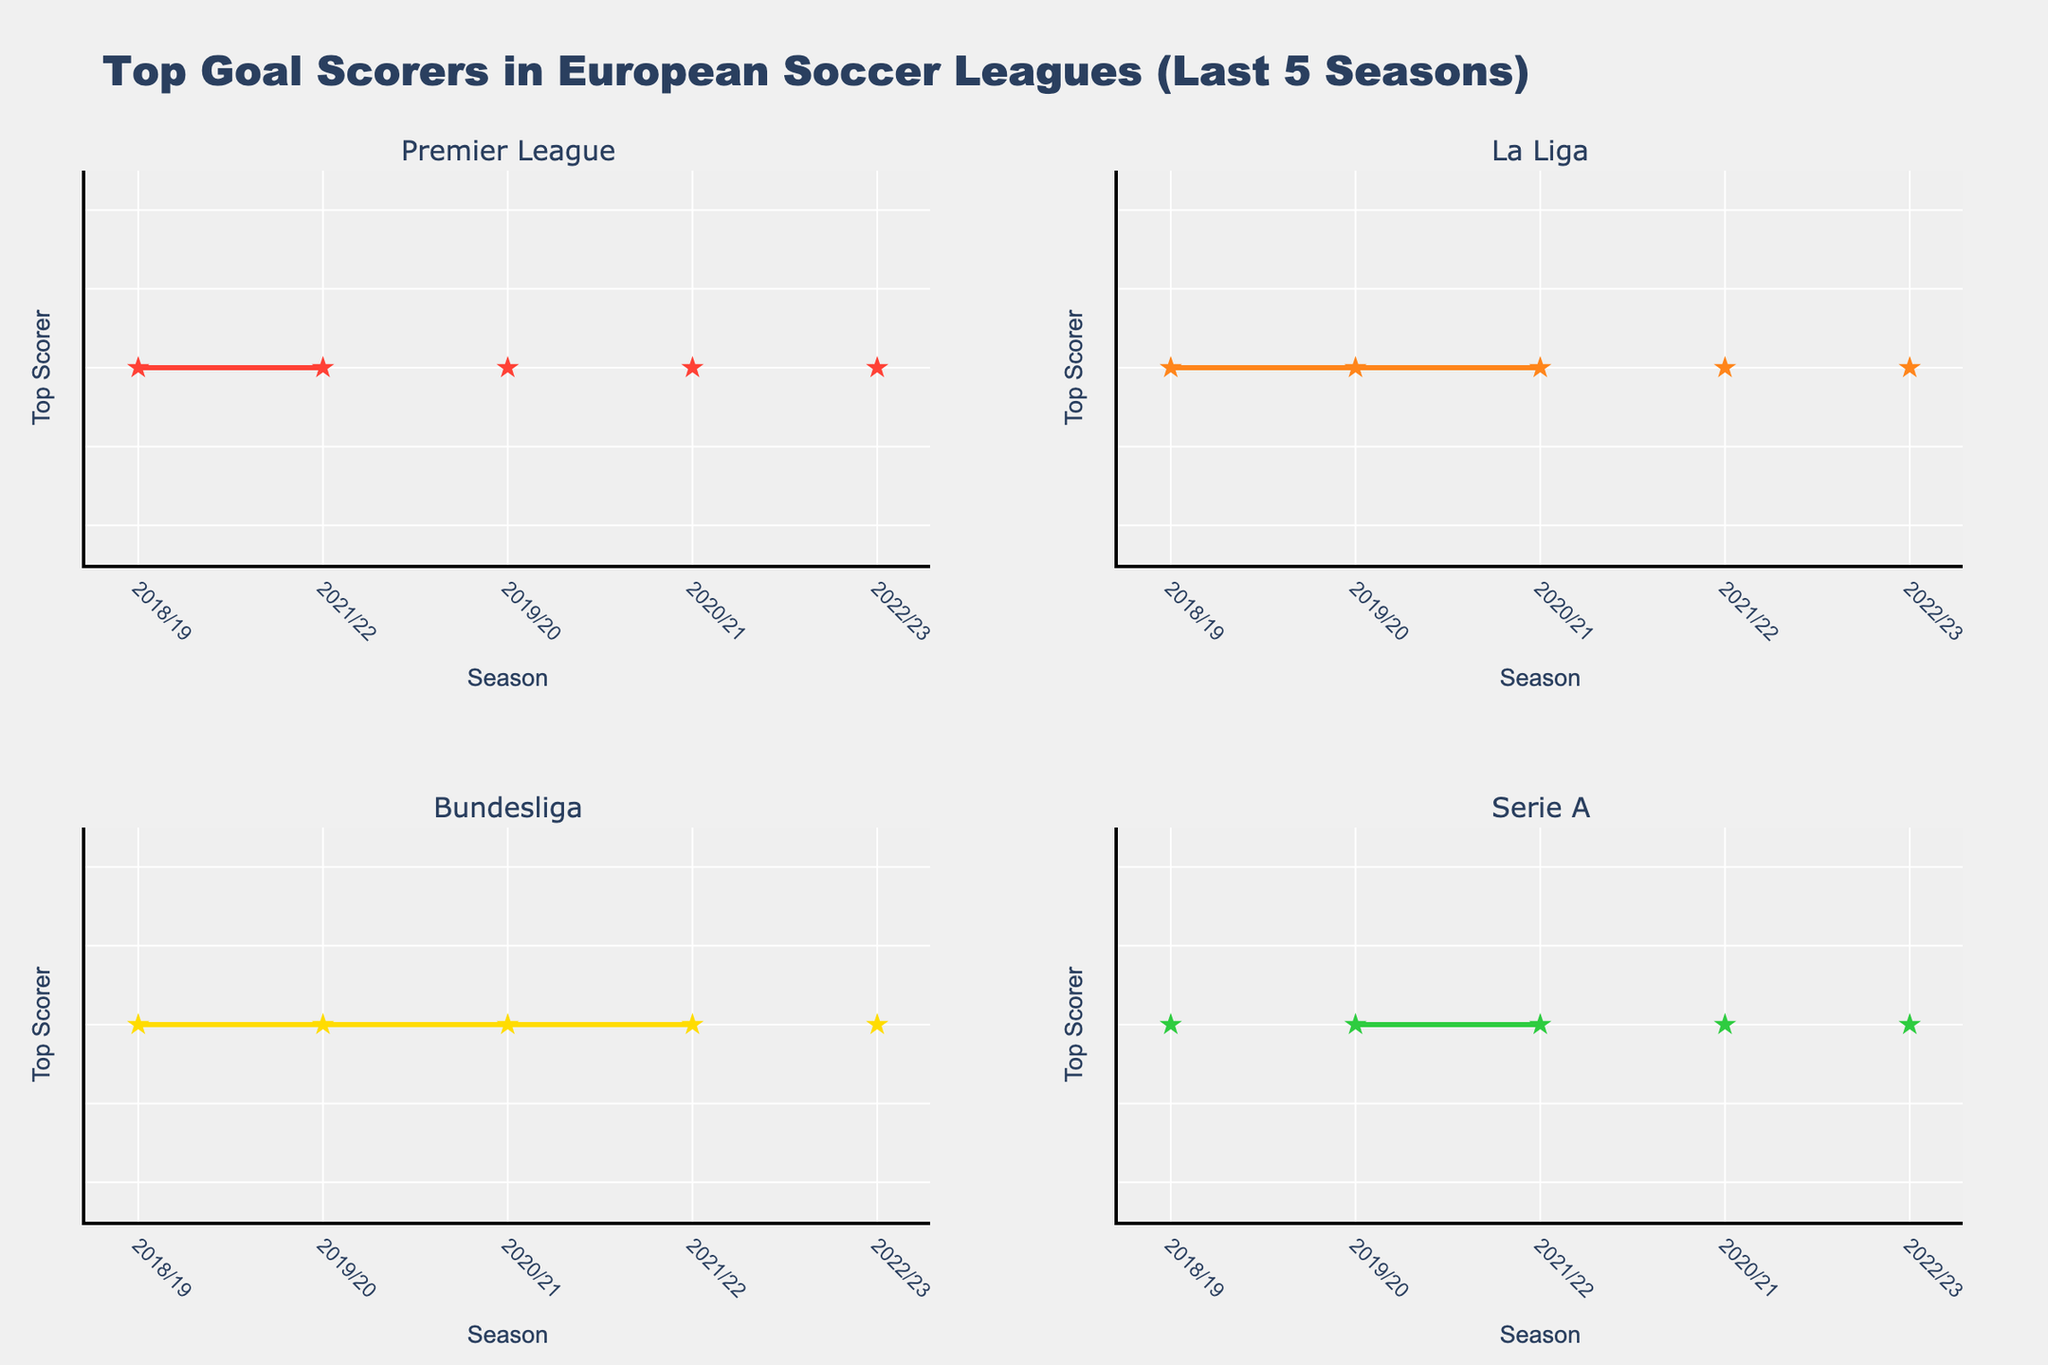What's the title of the figure? The title of the figure is positioned at the top center of the figure.
Answer: Tertiary Education and R&D Expenditure in OECD Countries What is the range of the y-axis for the Tertiary Enrollment Rate plot? The range of the y-axis is depicted on the left side of the Tertiary Enrollment Rate plot. It starts at 55% and extends to 120%.
Answer: 55% to 120% Which country has the highest Tertiary Enrollment Rate? By looking at the left subplot, it is clear that the data point with the highest y-value determines the country with the highest Tertiary Enrollment Rate.
Answer: Australia Of the countries depicted, which one spends the most on R&D as a percentage of GDP? In the right subplot, the data point with the highest value on the y-axis corresponds to the country with the highest R&D expenditure.
Answer: Israel What is the difference between the Tertiary Enrollment Rate of South Korea and Japan? The Tertiary Enrollment Rates of South Korea and Japan can be found in the left subplot. Subtracting Japan's rate from South Korea's rate gives the difference: 93.8% - 63.2% = 30.6%.
Answer: 30.6% How many countries have a Tertiary Enrollment Rate above 80%? By counting the data points above the 80% y-tick in the left subplot, we can see the number of countries.
Answer: 9 Compare the Research and Development Expenditure between the United States and France. In the right subplot, compare the y-values for the United States (3.07%) and France (2.2%). The United States spends more on R&D than France.
Answer: The United States What is the average Tertiary Enrollment Rate of the countries displayed? Adding up all Tertiary Enrollment Rates and dividing by the number of countries (113.1 + 93.8 + 88.9 + 88.2 + 87.9 + 85.7 + 82 + 82 + 81.2 + 79.7 + 77.8 + 70.2 + 68.9 + 67 + 65.6 + 63.5 + 63.2 + 62.5 + 60 + 59.6 = 1575.2, 1575.2/20 = 78.76)
Answer: 78.76 Which countries display both below-average Tertiary Enrollment Rates and above-average R&D Expenditure? First, calculate the averages. Then find countries where Enrollment < 78.76% and R&D Expenditure > 2.54%.
Answer: Japan, Germany, Sweden, Switzerland Does a higher Tertiary Enrollment Rate correlate with higher R&D expenditure? Judging by the scatter plots, many countries with high Tertiary Enrollment Rates do not necessarily have high R&D expenditure, indicating no strong positive correlation.
Answer: No 